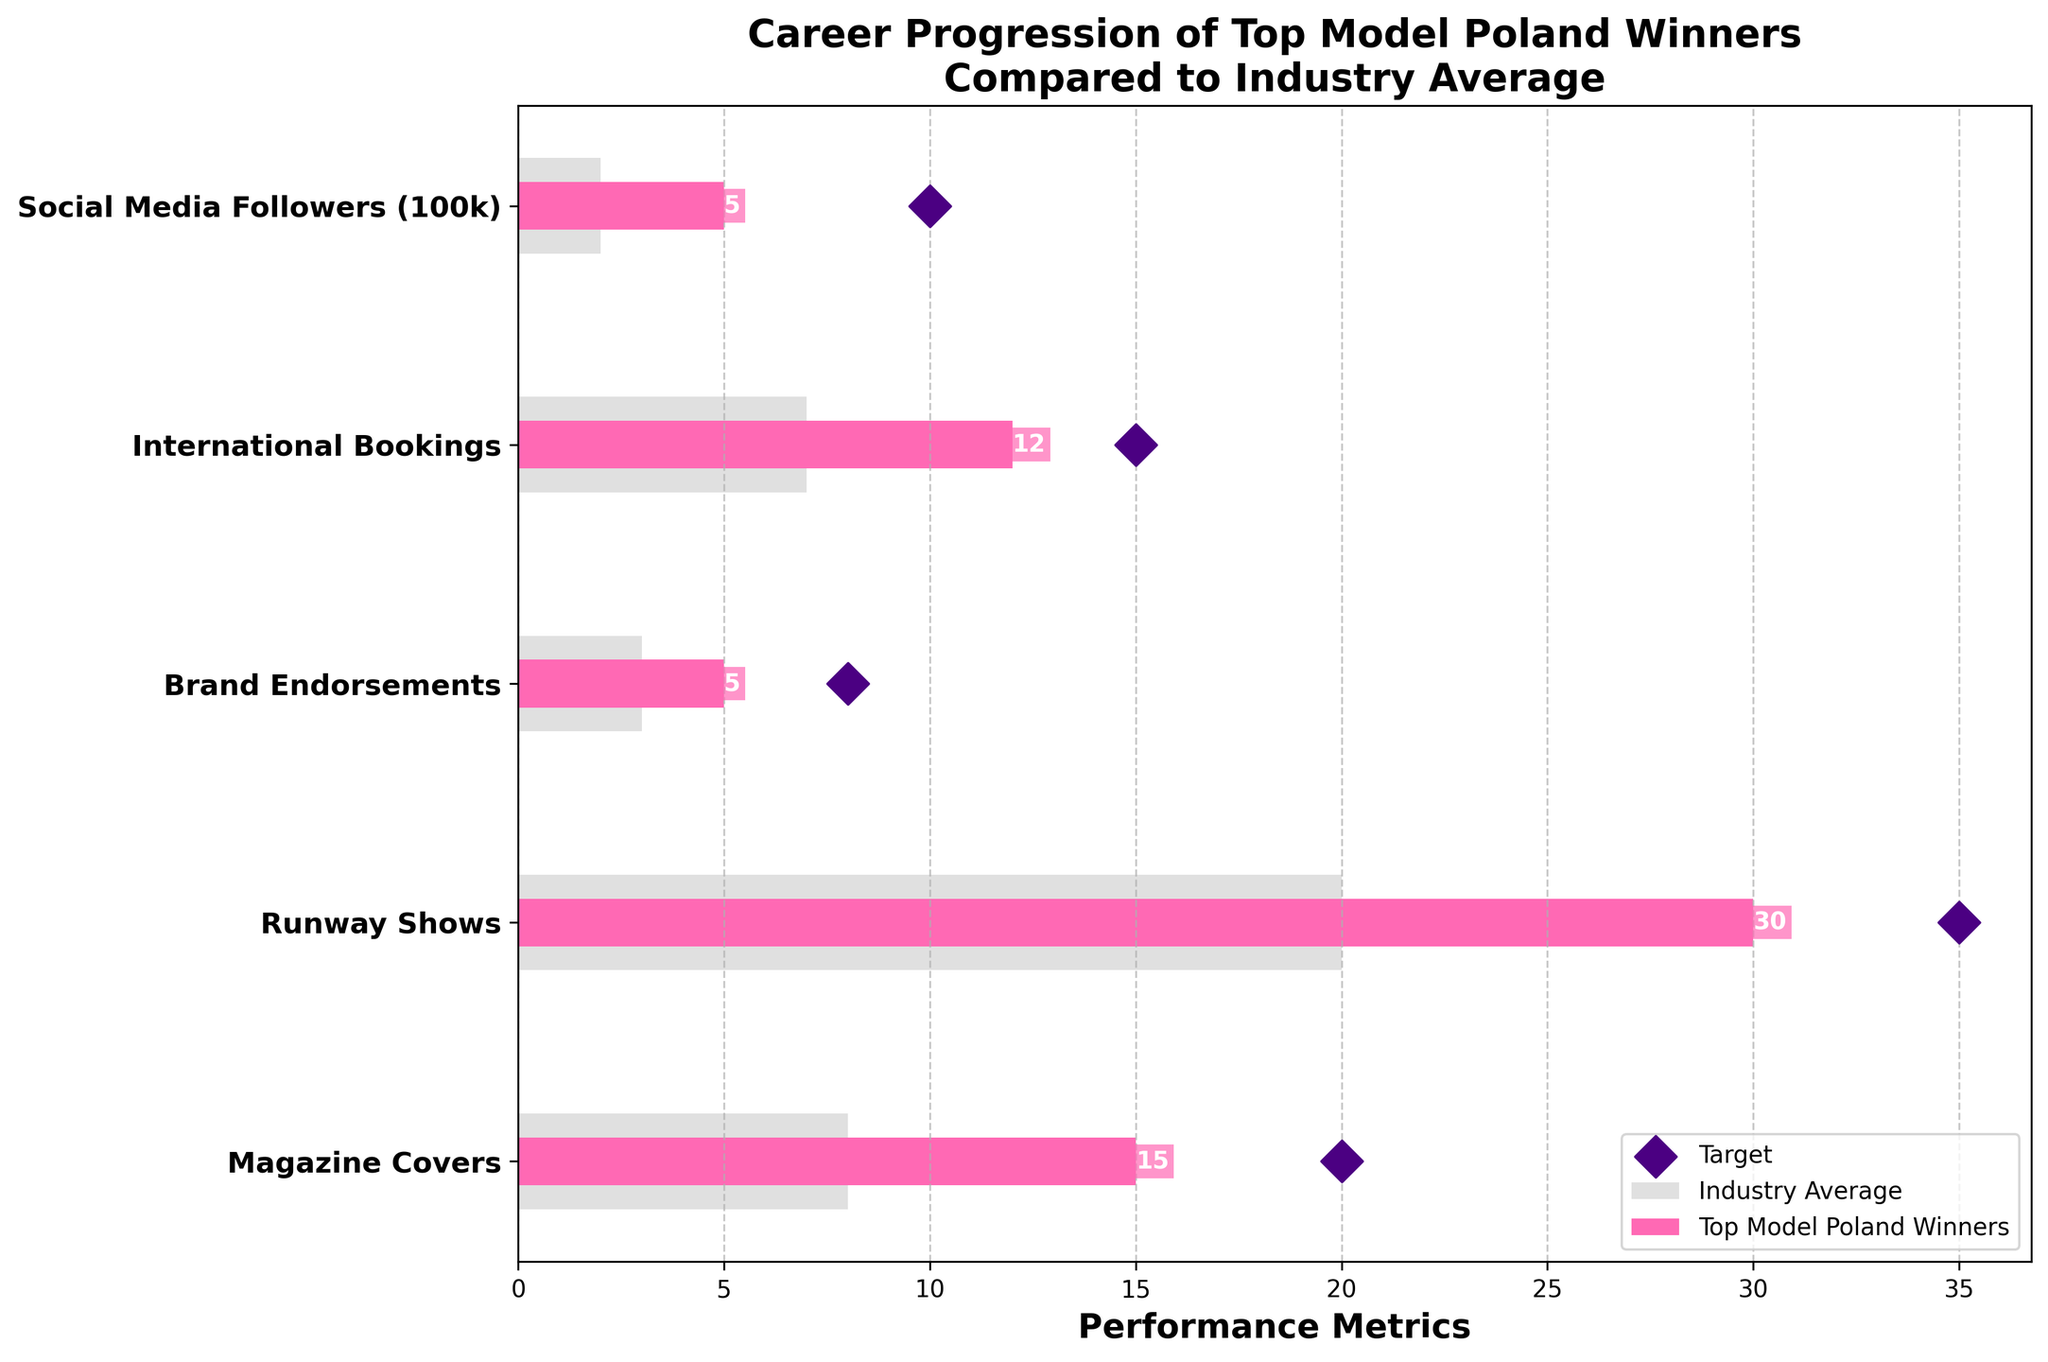what is the title of the figure? The title is typically located at the top of the plot. It provides a summary of what the figure represents, which in this case is "Career Progression of Top Model Poland Winners Compared to Industry Average".
Answer: Career Progression of Top Model Poland Winners Compared to Industry Average How many categories are being compared in the figure? The categories are typically displayed on the y-axis of a horizontal bar chart. In this figure, the y-axis lists five categories: Magazine Covers, Runway Shows, Brand Endorsements, International Bookings, and Social Media Followers (100k).
Answer: 5 What is the color used to represent the performance of Top Model Poland winners? In the legend, the color representing Top Model Poland winners is clearly marked. Here, it is highlighted in a pinkish color.
Answer: pink How many more magazine covers do Top Model Poland winners have compared to the industry average? To find this, you refer to the magazine covers category and subtract the comparative value (industry average) from the actual value (Top Model Poland winners): 15 (Actual) - 8 (Comparative).
Answer: 7 Which category has the largest gap between the actual performance and the target? To determine this, you need to find the difference between the target and actual values for each category and identify which has the largest difference. International Bookings has the largest gap: 15 (Target) - 12 (Actual) = 3.
Answer: International Bookings What is the average number of runway shows and international bookings done by Top Model Poland winners? To find this, you sum the actual values for both categories and divide by 2: (30 + 12) / 2.
Answer: 21 In which category do Top Model Poland winners most outperform the industry average? By comparing the actual and comparative values for each category, we see that Top Model Poland winners outperform the industry average the most in Runway Shows: 30 (Actual) - 20 (Comparative).
Answer: Runway Shows How many brand endorsements do Top Model Poland winners have compared to the target? Subtract the actual number of brand endorsements from the target value to find the difference: 8 (Target) - 5 (Actual).
Answer: 3 Are Top Model Poland winners meeting their targets for social media followers? Compare the actual number of social media followers to the target. The actual value is 5, and the target is 10, thus they are not meeting their targets.
Answer: No Which category has the least difference between the actual performance of Top Model Poland winners and the industry average? To determine this, calculate the difference between actual and comparative values across all categories and find the smallest difference. For Brand Endorsements, the difference is: 5 (Actual) - 3 (Comparative) = 2, which is the smallest.
Answer: Brand Endorsements 